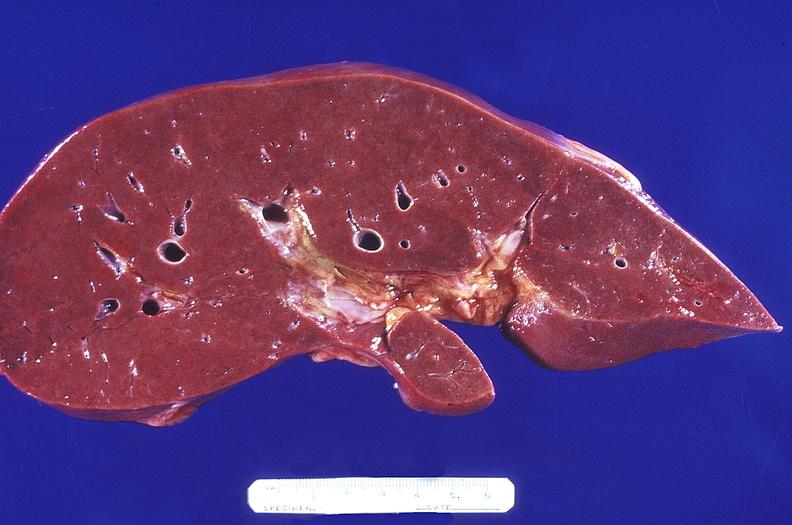s hepatobiliary present?
Answer the question using a single word or phrase. Yes 